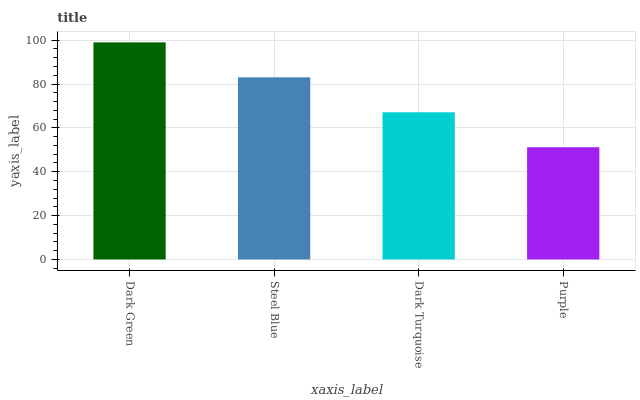Is Purple the minimum?
Answer yes or no. Yes. Is Dark Green the maximum?
Answer yes or no. Yes. Is Steel Blue the minimum?
Answer yes or no. No. Is Steel Blue the maximum?
Answer yes or no. No. Is Dark Green greater than Steel Blue?
Answer yes or no. Yes. Is Steel Blue less than Dark Green?
Answer yes or no. Yes. Is Steel Blue greater than Dark Green?
Answer yes or no. No. Is Dark Green less than Steel Blue?
Answer yes or no. No. Is Steel Blue the high median?
Answer yes or no. Yes. Is Dark Turquoise the low median?
Answer yes or no. Yes. Is Dark Green the high median?
Answer yes or no. No. Is Steel Blue the low median?
Answer yes or no. No. 